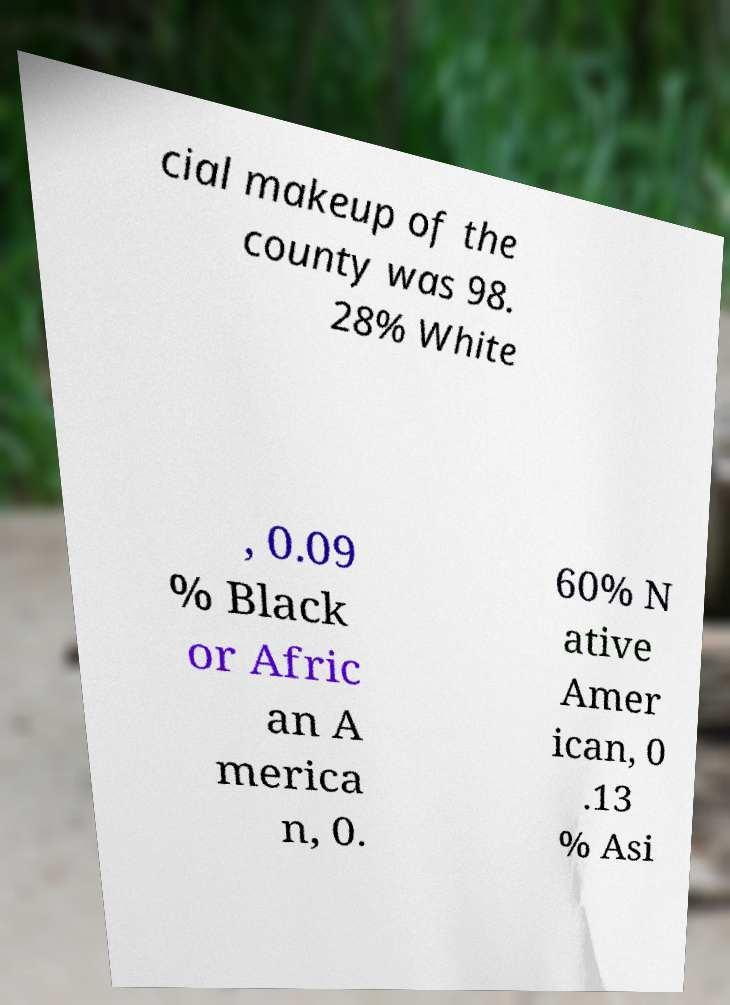Can you accurately transcribe the text from the provided image for me? cial makeup of the county was 98. 28% White , 0.09 % Black or Afric an A merica n, 0. 60% N ative Amer ican, 0 .13 % Asi 